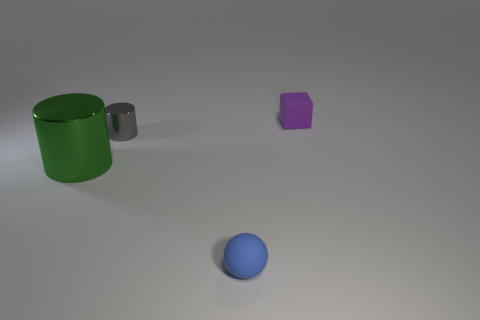Is there anything else that has the same size as the green thing?
Keep it short and to the point. No. What is the material of the cylinder to the left of the tiny object that is to the left of the rubber thing that is to the left of the small purple block?
Offer a very short reply. Metal. Is the shape of the tiny blue thing the same as the big green thing?
Keep it short and to the point. No. How many shiny things are either purple cubes or big gray cubes?
Your answer should be compact. 0. How many brown metal objects are there?
Your answer should be very brief. 0. There is a cylinder that is the same size as the purple matte block; what color is it?
Offer a terse response. Gray. Does the gray cylinder have the same size as the green cylinder?
Keep it short and to the point. No. Is the size of the purple block the same as the rubber object that is in front of the purple matte block?
Provide a succinct answer. Yes. What color is the object that is both right of the tiny gray shiny thing and in front of the tiny cylinder?
Make the answer very short. Blue. Are there more blue rubber things behind the small purple cube than big green metal objects that are right of the gray cylinder?
Offer a very short reply. No. 